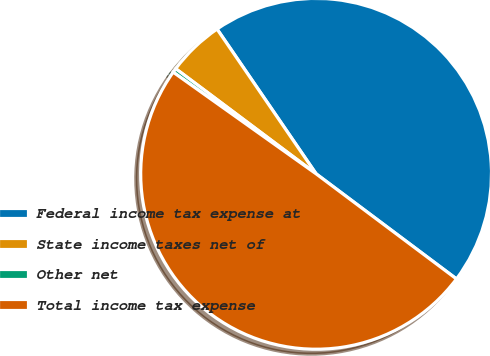Convert chart. <chart><loc_0><loc_0><loc_500><loc_500><pie_chart><fcel>Federal income tax expense at<fcel>State income taxes net of<fcel>Other net<fcel>Total income tax expense<nl><fcel>44.78%<fcel>5.22%<fcel>0.39%<fcel>49.61%<nl></chart> 